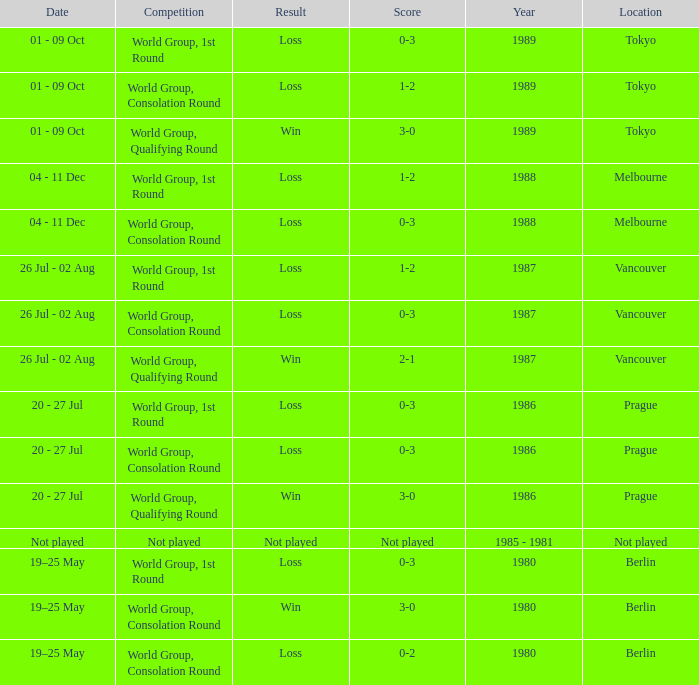What is the competition when the result is loss in berlin with a score of 0-3? World Group, 1st Round. 